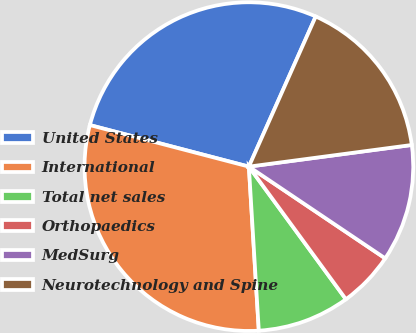<chart> <loc_0><loc_0><loc_500><loc_500><pie_chart><fcel>United States<fcel>International<fcel>Total net sales<fcel>Orthopaedics<fcel>MedSurg<fcel>Neurotechnology and Spine<nl><fcel>27.6%<fcel>30.03%<fcel>9.09%<fcel>5.52%<fcel>11.53%<fcel>16.23%<nl></chart> 